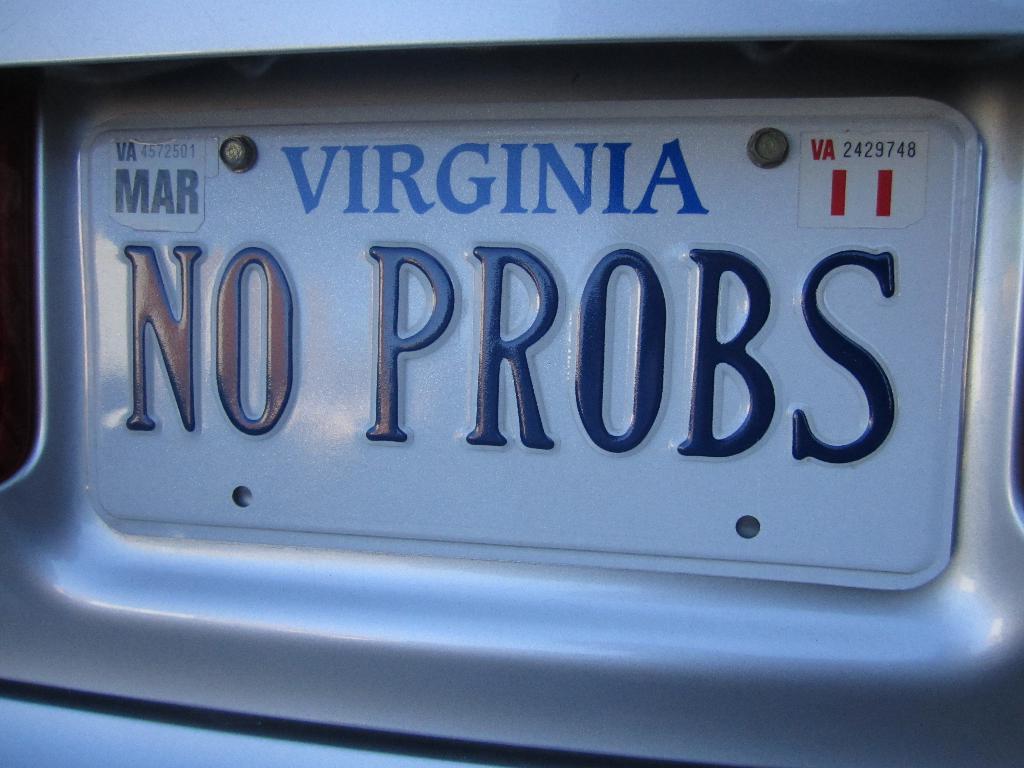In which month does this license plate expire?
Your response must be concise. March. What state is the plate from?
Give a very brief answer. Virginia. 